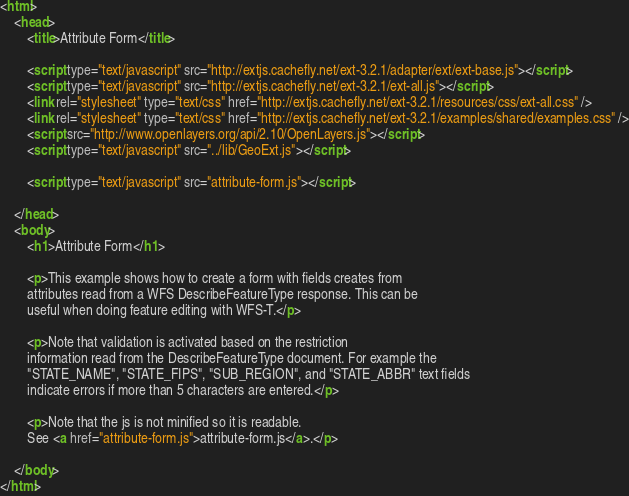<code> <loc_0><loc_0><loc_500><loc_500><_HTML_><html>
    <head>
        <title>Attribute Form</title>

        <script type="text/javascript" src="http://extjs.cachefly.net/ext-3.2.1/adapter/ext/ext-base.js"></script>
        <script type="text/javascript" src="http://extjs.cachefly.net/ext-3.2.1/ext-all.js"></script>
        <link rel="stylesheet" type="text/css" href="http://extjs.cachefly.net/ext-3.2.1/resources/css/ext-all.css" />
        <link rel="stylesheet" type="text/css" href="http://extjs.cachefly.net/ext-3.2.1/examples/shared/examples.css" />
        <script src="http://www.openlayers.org/api/2.10/OpenLayers.js"></script>
        <script type="text/javascript" src="../lib/GeoExt.js"></script>

        <script type="text/javascript" src="attribute-form.js"></script>

    </head>
    <body>
        <h1>Attribute Form</h1>

        <p>This example shows how to create a form with fields creates from
        attributes read from a WFS DescribeFeatureType response. This can be
        useful when doing feature editing with WFS-T.</p>

        <p>Note that validation is activated based on the restriction
        information read from the DescribeFeatureType document. For example the
        "STATE_NAME", "STATE_FIPS", "SUB_REGION", and "STATE_ABBR" text fields
        indicate errors if more than 5 characters are entered.</p>

        <p>Note that the js is not minified so it is readable.
        See <a href="attribute-form.js">attribute-form.js</a>.</p>

    </body>
</html>
</code> 